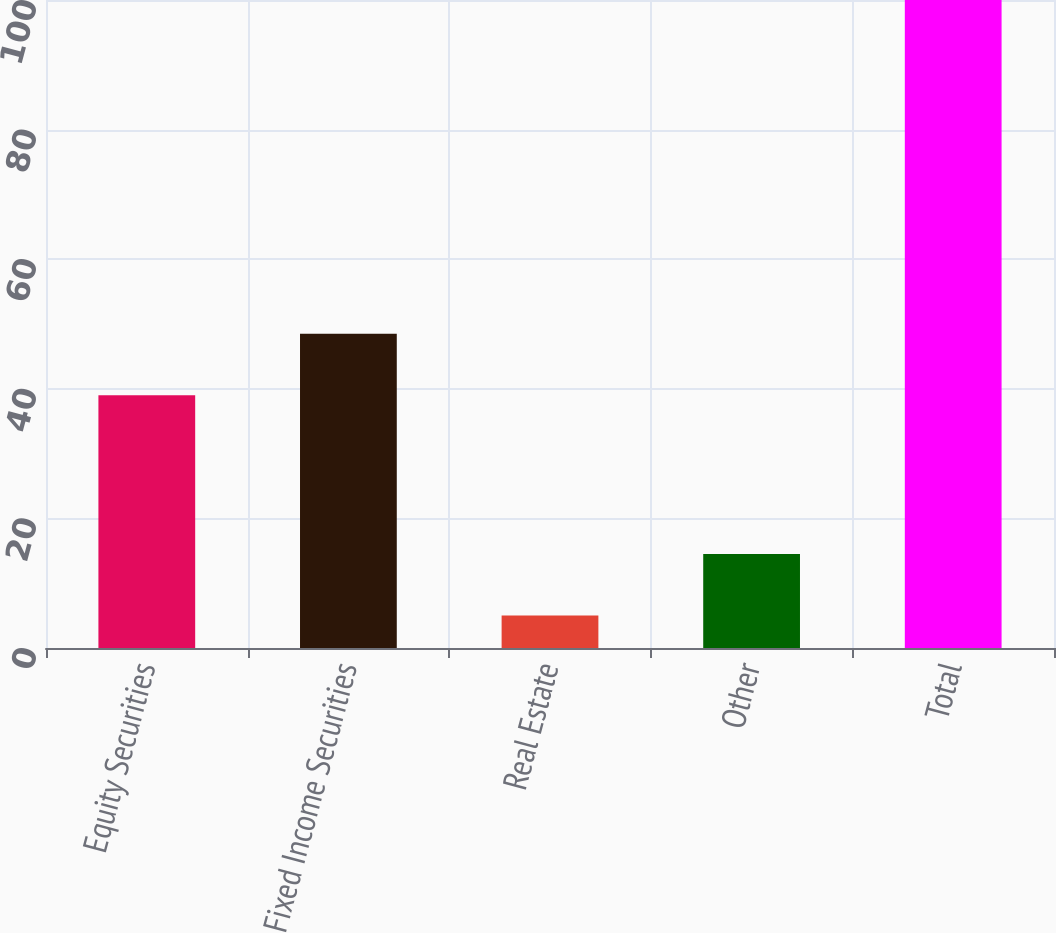Convert chart. <chart><loc_0><loc_0><loc_500><loc_500><bar_chart><fcel>Equity Securities<fcel>Fixed Income Securities<fcel>Real Estate<fcel>Other<fcel>Total<nl><fcel>39<fcel>48.5<fcel>5<fcel>14.5<fcel>100<nl></chart> 